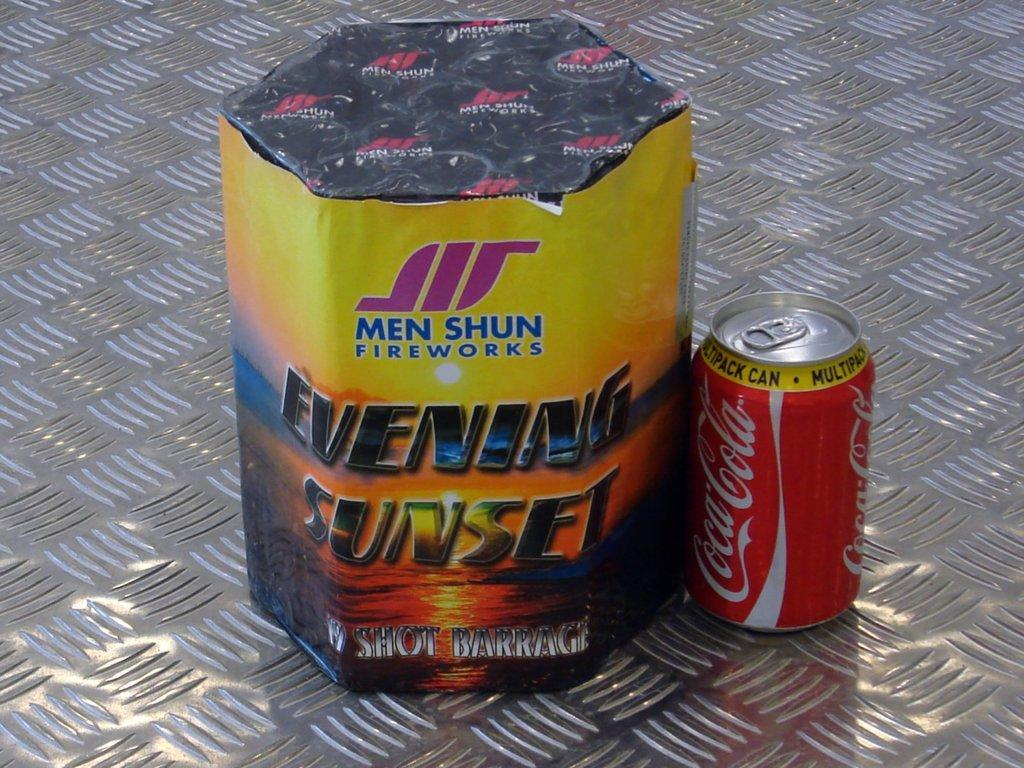Provide a one-sentence caption for the provided image. Celebration items for the 4th of July, Men Shun Fireworks and a Coca Cola Soda Can. 